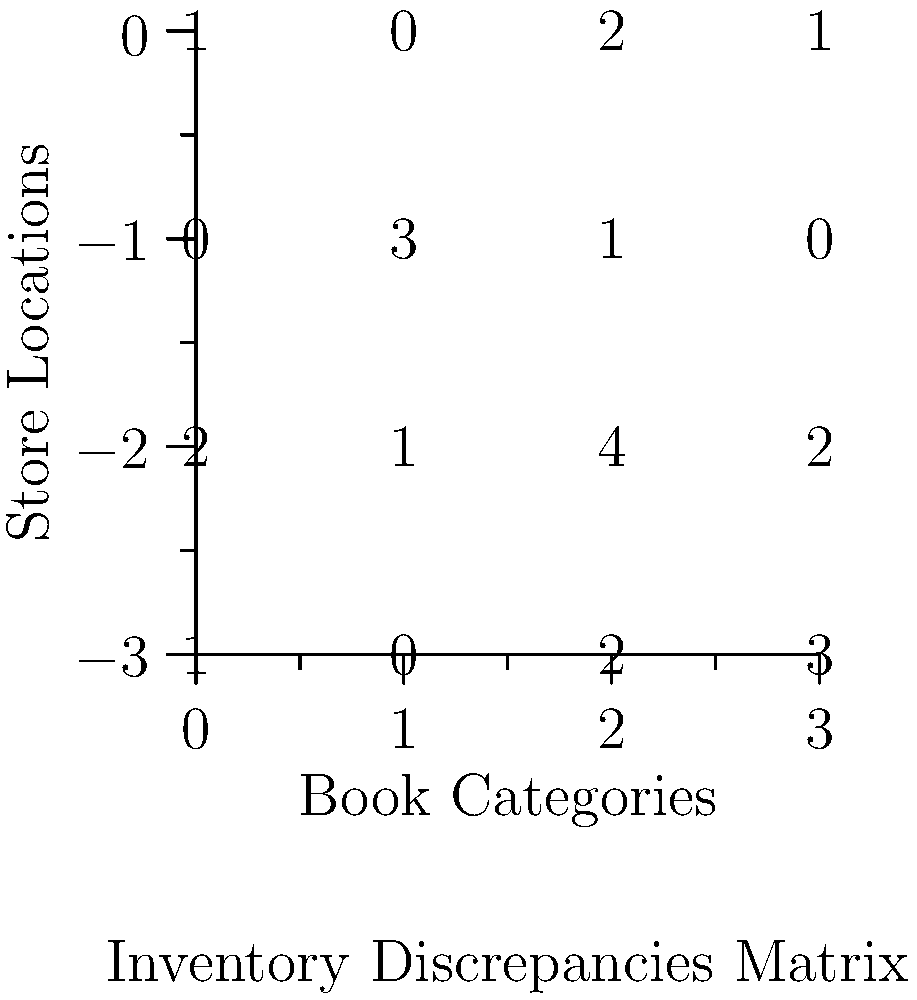The matrix above represents inventory discrepancies across different book categories and store locations for a suspicious book seller. Using group theory and symmetry analysis, which pattern in the discrepancies could potentially reveal a systematic fraud scheme? To analyze this matrix for patterns using group theory, we can follow these steps:

1. Observe the matrix structure:
   $$ \begin{pmatrix}
   1 & 0 & 2 & 1 \\
   0 & 3 & 1 & 0 \\
   2 & 1 & 4 & 2 \\
   1 & 0 & 2 & 3
   \end{pmatrix} $$

2. Look for symmetries or repeated patterns:
   - The first and third rows have a similar pattern (1,0,2,1) and (2,1,4,2), which is a scaling by 2.
   - The first and fourth columns are identical except for the last element.

3. Apply group theory concepts:
   - The scaling between rows 1 and 3 suggests a multiplicative group action.
   - The similarity between columns 1 and 4 indicates a potential cyclic group structure.

4. Analyze the diagonal:
   - The diagonal elements (1,3,4,3) show an increasing then decreasing pattern.
   - This could represent a rotational symmetry in the group of discrepancies.

5. Consider the implications:
   - The scaling between rows could indicate a proportional increase in discrepancies across store locations.
   - The similarity between columns might suggest a repeating pattern in how discrepancies are distributed across book categories.
   - The diagonal pattern could reveal a cyclic nature in how the fraud is perpetrated across both dimensions.

6. Conclusion:
   The most revealing pattern is the scaling relationship between rows 1 and 3, as it suggests a consistent doubling of discrepancies between two store locations across all book categories. This systematic scaling is the strongest indicator of a potential fraud scheme.
Answer: Scaling relationship between rows 1 and 3 